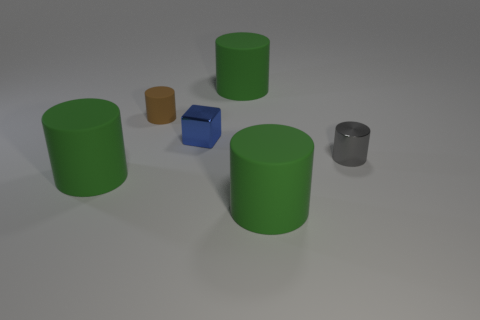What size is the metal thing that is to the left of the large object that is behind the metal object that is on the left side of the gray object?
Keep it short and to the point. Small. How many other things are the same material as the gray cylinder?
Give a very brief answer. 1. What is the color of the big rubber object behind the tiny brown rubber cylinder?
Offer a very short reply. Green. There is a green thing in front of the big green matte object that is on the left side of the big rubber thing that is behind the metallic cube; what is its material?
Your response must be concise. Rubber. Is there a large green thing that has the same shape as the small gray object?
Keep it short and to the point. Yes. The blue metal thing that is the same size as the gray object is what shape?
Ensure brevity in your answer.  Cube. How many objects are to the right of the tiny brown rubber object and to the left of the small gray metal thing?
Your response must be concise. 3. Are there fewer tiny objects that are behind the gray cylinder than big green balls?
Ensure brevity in your answer.  No. Is there a blue metallic block of the same size as the brown object?
Your response must be concise. Yes. What is the color of the cube that is made of the same material as the gray cylinder?
Provide a succinct answer. Blue. 